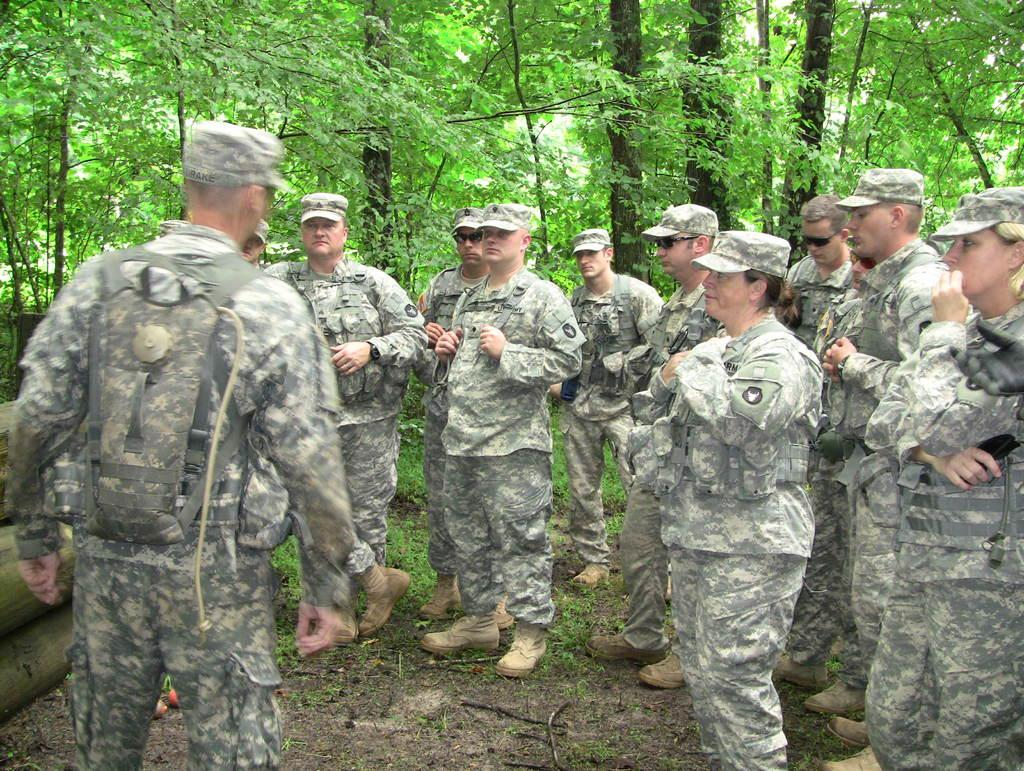What is happening in the image? There are people standing in the image. What can be seen on the left side of the image? There are wooden branches on the surface on the left side of the image. What is visible in the background of the image? There are trees in the background of the image. What type of advertisement can be seen on the wooden branches in the image? There is no advertisement present on the wooden branches in the image. 